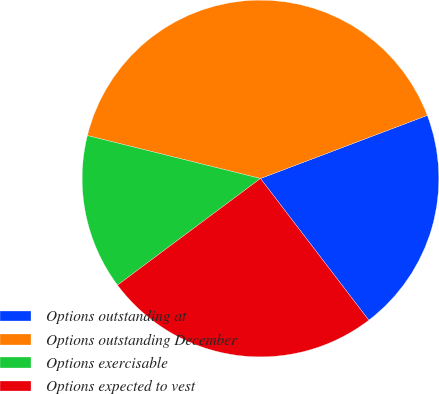Convert chart. <chart><loc_0><loc_0><loc_500><loc_500><pie_chart><fcel>Options outstanding at<fcel>Options outstanding December<fcel>Options exercisable<fcel>Options expected to vest<nl><fcel>20.37%<fcel>40.37%<fcel>14.07%<fcel>25.19%<nl></chart> 